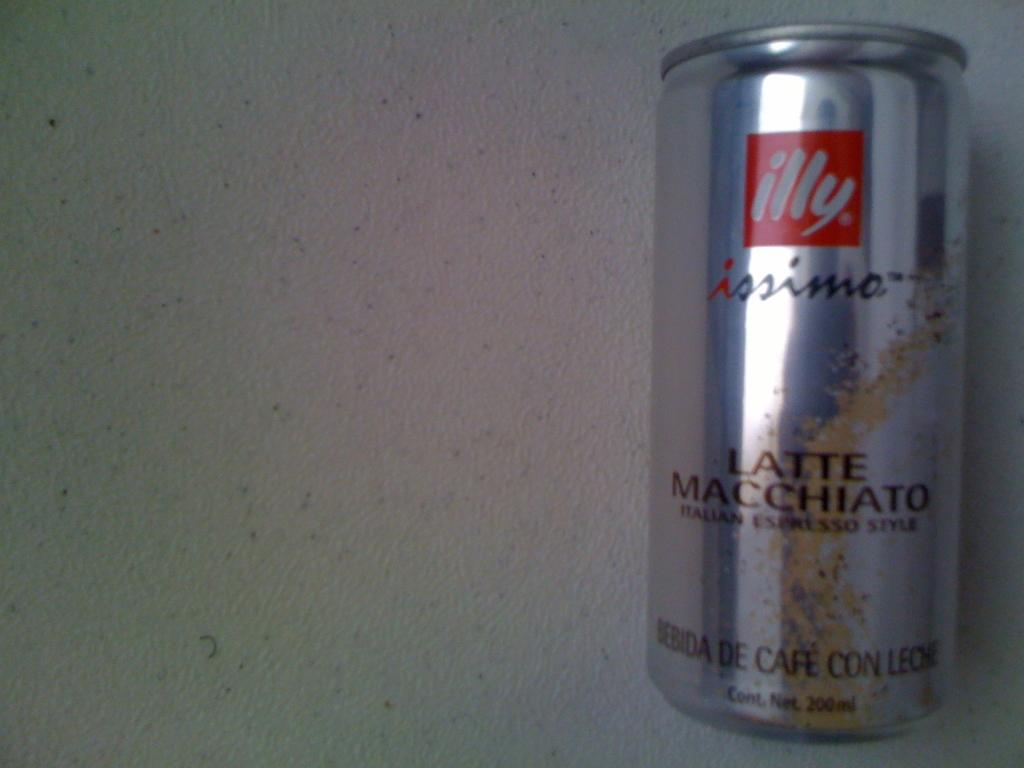<image>
Present a compact description of the photo's key features. a can of ILLY Issimo lies on a speckeled surface 